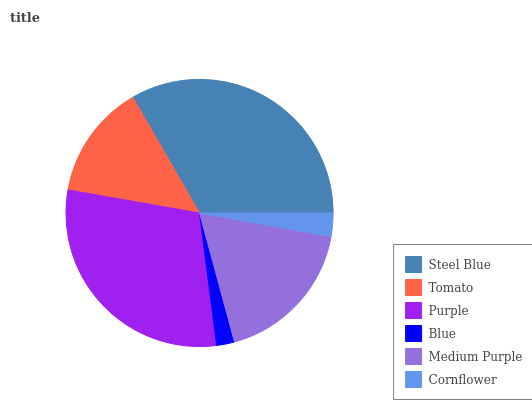Is Blue the minimum?
Answer yes or no. Yes. Is Steel Blue the maximum?
Answer yes or no. Yes. Is Tomato the minimum?
Answer yes or no. No. Is Tomato the maximum?
Answer yes or no. No. Is Steel Blue greater than Tomato?
Answer yes or no. Yes. Is Tomato less than Steel Blue?
Answer yes or no. Yes. Is Tomato greater than Steel Blue?
Answer yes or no. No. Is Steel Blue less than Tomato?
Answer yes or no. No. Is Medium Purple the high median?
Answer yes or no. Yes. Is Tomato the low median?
Answer yes or no. Yes. Is Purple the high median?
Answer yes or no. No. Is Cornflower the low median?
Answer yes or no. No. 